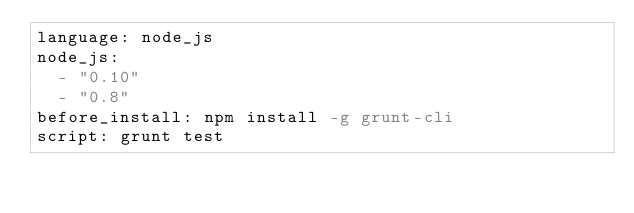<code> <loc_0><loc_0><loc_500><loc_500><_YAML_>language: node_js
node_js:
  - "0.10"
  - "0.8"
before_install: npm install -g grunt-cli
script: grunt test</code> 